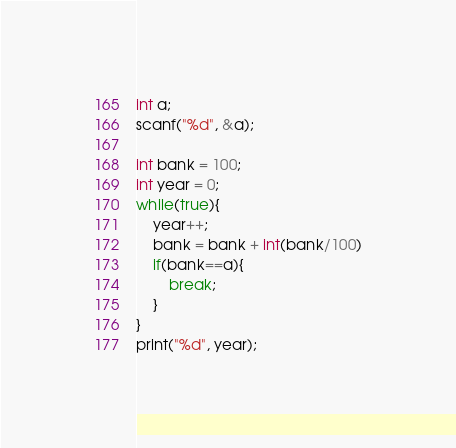Convert code to text. <code><loc_0><loc_0><loc_500><loc_500><_C_>int a;
scanf("%d", &a);

int bank = 100;
int year = 0;
while(true){
	year++;
    bank = bank + int(bank/100)
    if(bank==a){
    	break;
    }
}
print("%d", year);</code> 